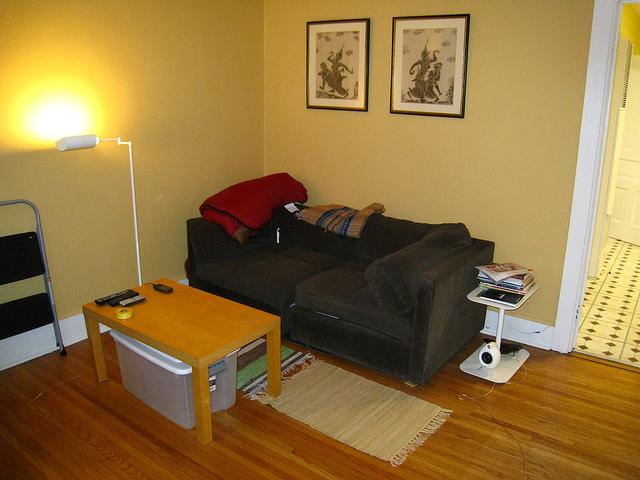What color lid is on top of the tub?
Quick response, please. White. Is the table empty?
Write a very short answer. No. What color are the walls?
Write a very short answer. Yellow. Where is the cell phone?
Write a very short answer. On table. Is there natural light in the room?
Answer briefly. No. Is there a window in the room?
Short answer required. No. 